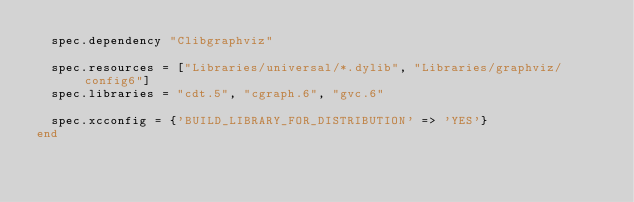<code> <loc_0><loc_0><loc_500><loc_500><_Ruby_>  spec.dependency "Clibgraphviz"

  spec.resources = ["Libraries/universal/*.dylib", "Libraries/graphviz/config6"]
  spec.libraries = "cdt.5", "cgraph.6", "gvc.6"

  spec.xcconfig = {'BUILD_LIBRARY_FOR_DISTRIBUTION' => 'YES'}
end




</code> 